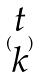Convert formula to latex. <formula><loc_0><loc_0><loc_500><loc_500>( \begin{matrix} t \\ k \end{matrix} )</formula> 